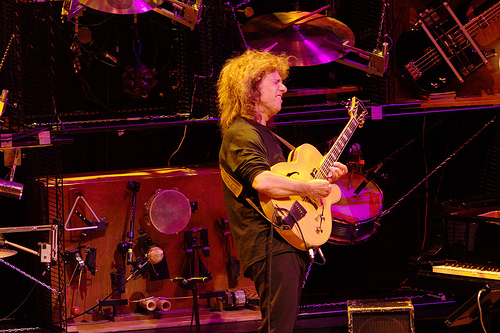<image>
Can you confirm if the man is under the cymbal? Yes. The man is positioned underneath the cymbal, with the cymbal above it in the vertical space. Is there a drums above the person? Yes. The drums is positioned above the person in the vertical space, higher up in the scene. 